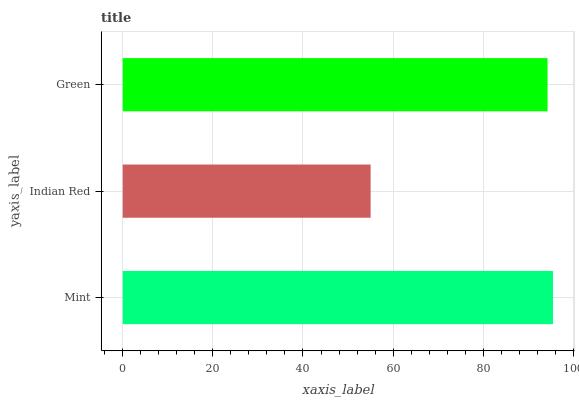Is Indian Red the minimum?
Answer yes or no. Yes. Is Mint the maximum?
Answer yes or no. Yes. Is Green the minimum?
Answer yes or no. No. Is Green the maximum?
Answer yes or no. No. Is Green greater than Indian Red?
Answer yes or no. Yes. Is Indian Red less than Green?
Answer yes or no. Yes. Is Indian Red greater than Green?
Answer yes or no. No. Is Green less than Indian Red?
Answer yes or no. No. Is Green the high median?
Answer yes or no. Yes. Is Green the low median?
Answer yes or no. Yes. Is Mint the high median?
Answer yes or no. No. Is Indian Red the low median?
Answer yes or no. No. 